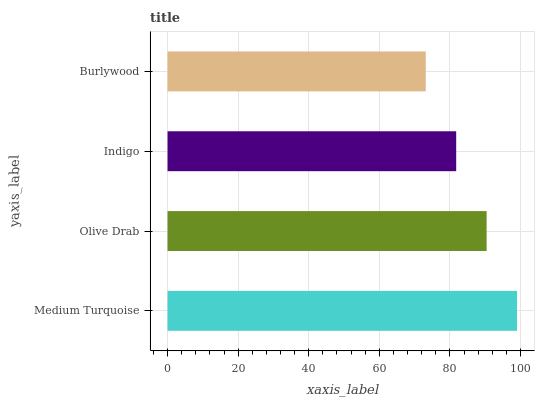Is Burlywood the minimum?
Answer yes or no. Yes. Is Medium Turquoise the maximum?
Answer yes or no. Yes. Is Olive Drab the minimum?
Answer yes or no. No. Is Olive Drab the maximum?
Answer yes or no. No. Is Medium Turquoise greater than Olive Drab?
Answer yes or no. Yes. Is Olive Drab less than Medium Turquoise?
Answer yes or no. Yes. Is Olive Drab greater than Medium Turquoise?
Answer yes or no. No. Is Medium Turquoise less than Olive Drab?
Answer yes or no. No. Is Olive Drab the high median?
Answer yes or no. Yes. Is Indigo the low median?
Answer yes or no. Yes. Is Burlywood the high median?
Answer yes or no. No. Is Burlywood the low median?
Answer yes or no. No. 